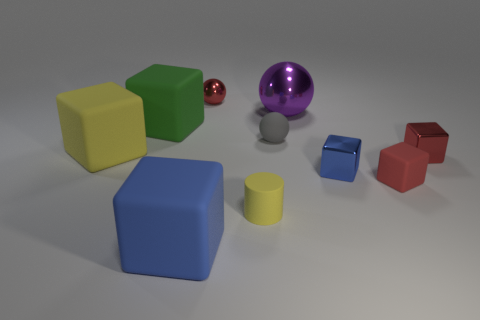Subtract all red metal blocks. How many blocks are left? 5 Subtract all spheres. How many objects are left? 7 Subtract all purple balls. How many balls are left? 2 Subtract all purple cylinders. How many red spheres are left? 1 Subtract all yellow spheres. Subtract all blue rubber cubes. How many objects are left? 9 Add 4 yellow rubber cylinders. How many yellow rubber cylinders are left? 5 Add 6 metallic objects. How many metallic objects exist? 10 Subtract 0 gray blocks. How many objects are left? 10 Subtract 1 cylinders. How many cylinders are left? 0 Subtract all purple balls. Subtract all brown cylinders. How many balls are left? 2 